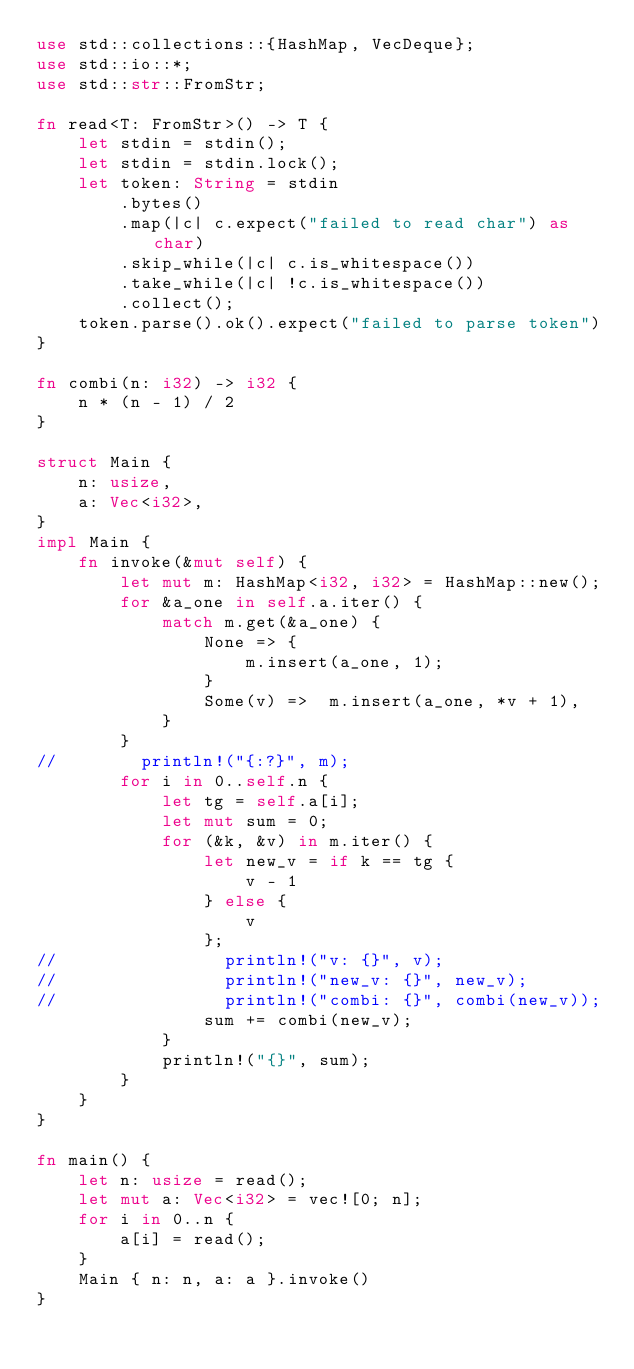<code> <loc_0><loc_0><loc_500><loc_500><_Rust_>use std::collections::{HashMap, VecDeque};
use std::io::*;
use std::str::FromStr;

fn read<T: FromStr>() -> T {
    let stdin = stdin();
    let stdin = stdin.lock();
    let token: String = stdin
        .bytes()
        .map(|c| c.expect("failed to read char") as char)
        .skip_while(|c| c.is_whitespace())
        .take_while(|c| !c.is_whitespace())
        .collect();
    token.parse().ok().expect("failed to parse token")
}

fn combi(n: i32) -> i32 {
    n * (n - 1) / 2
}

struct Main {
    n: usize,
    a: Vec<i32>,
}
impl Main {
    fn invoke(&mut self) {
        let mut m: HashMap<i32, i32> = HashMap::new();
        for &a_one in self.a.iter() {
            match m.get(&a_one) {
                None => {
                    m.insert(a_one, 1);
                }
                Some(v) =>  m.insert(a_one, *v + 1),
            }
        }
//        println!("{:?}", m);
        for i in 0..self.n {
            let tg = self.a[i];
            let mut sum = 0;
            for (&k, &v) in m.iter() {
                let new_v = if k == tg {
                    v - 1
                } else {
                    v
                };
//                println!("v: {}", v);
//                println!("new_v: {}", new_v);
//                println!("combi: {}", combi(new_v));
                sum += combi(new_v);
            }
            println!("{}", sum);
        }
    }
}

fn main() {
    let n: usize = read();
    let mut a: Vec<i32> = vec![0; n];
    for i in 0..n {
        a[i] = read();
    }
    Main { n: n, a: a }.invoke()
}
</code> 